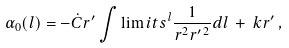<formula> <loc_0><loc_0><loc_500><loc_500>\alpha _ { 0 } ( l ) = - \dot { C } r ^ { \prime } \int \lim i t s ^ { l } \frac { 1 } { r ^ { 2 } r ^ { \prime \, 2 } } d l \, + \, k r ^ { \prime } \, ,</formula> 